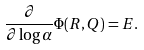Convert formula to latex. <formula><loc_0><loc_0><loc_500><loc_500>\frac { \partial } { \partial \log \alpha } \Phi ( R , Q ) = E .</formula> 